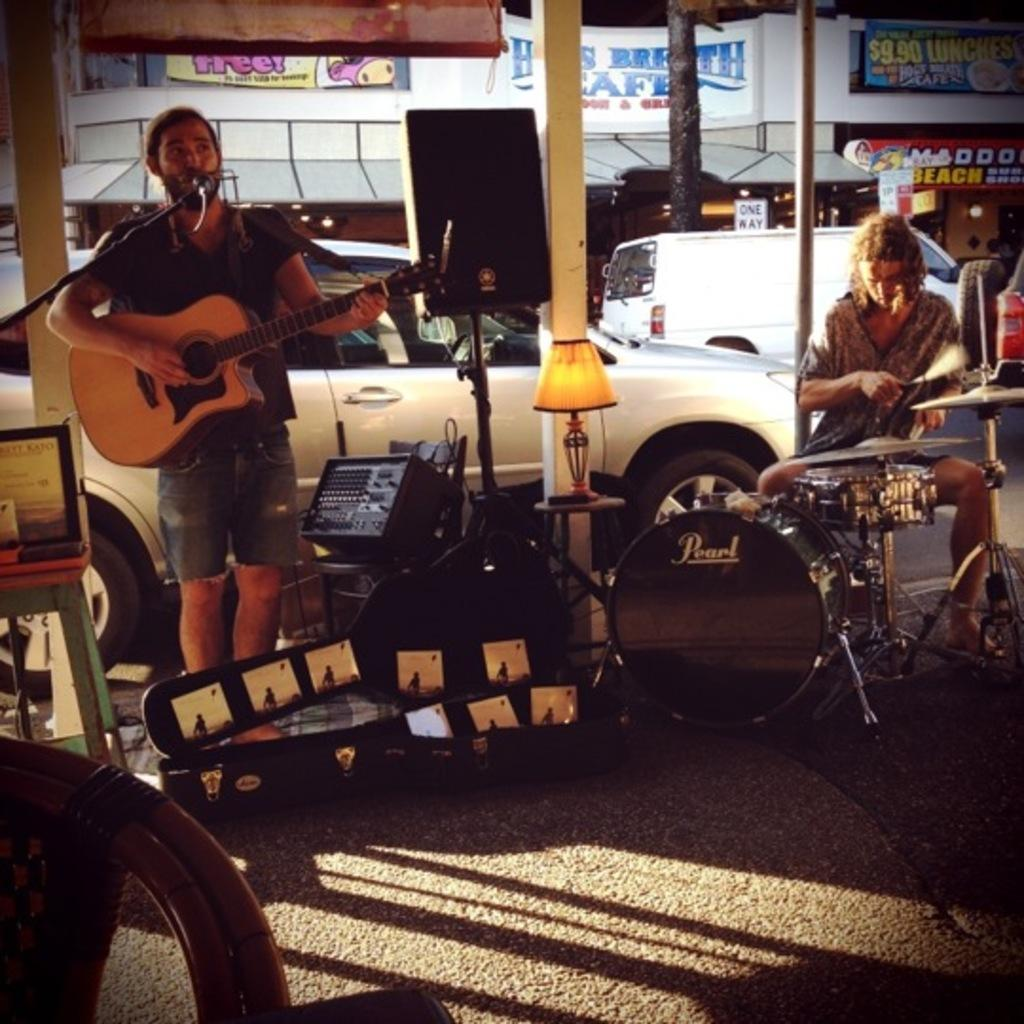How many people are in the image? There are two people in the image. What are the two people doing in the image? The two people are playing a musical instrument. Where is the scene taking place? The scene takes place on a road. What else can be seen in the image besides the people and their instruments? There are vehicles visible in the image. What is visible in the background of the image? There is a building in the background of the image. What riddle is written on the page held by the person on the left? There is no page or riddle present in the image. 